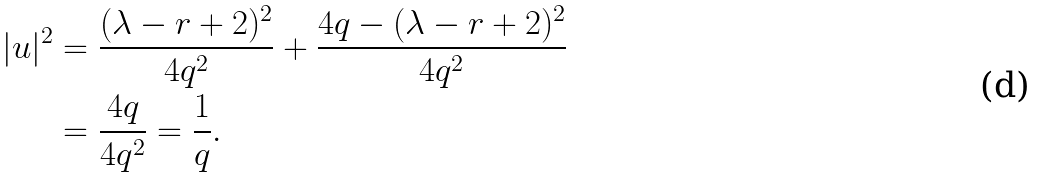<formula> <loc_0><loc_0><loc_500><loc_500>| u | ^ { 2 } & = \frac { ( \lambda - r + 2 ) ^ { 2 } } { 4 q ^ { 2 } } + \frac { 4 q - ( \lambda - r + 2 ) ^ { 2 } } { 4 q ^ { 2 } } \\ & = \frac { 4 q } { 4 q ^ { 2 } } = \frac { 1 } { q } .</formula> 